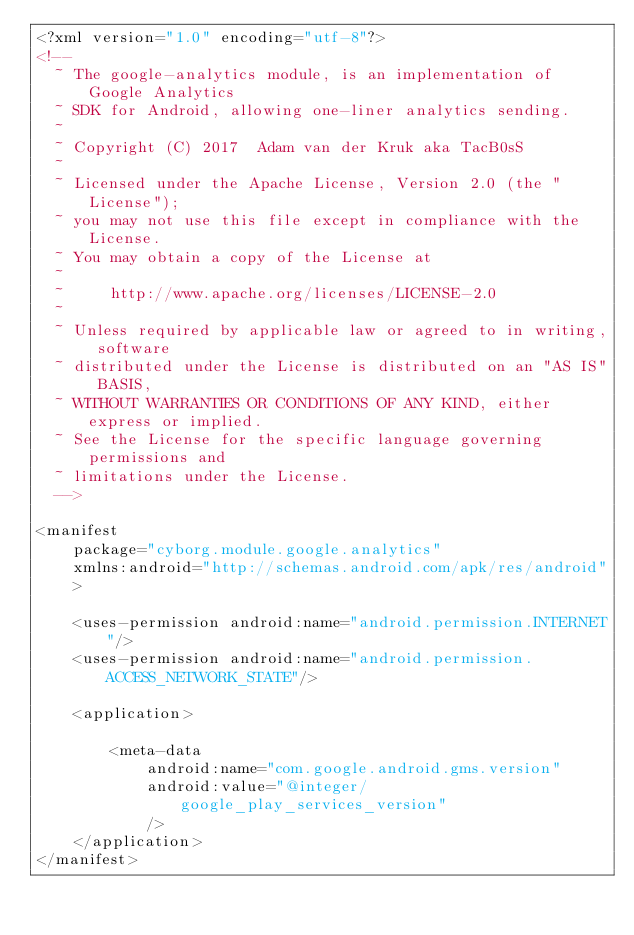Convert code to text. <code><loc_0><loc_0><loc_500><loc_500><_XML_><?xml version="1.0" encoding="utf-8"?>
<!--
  ~ The google-analytics module, is an implementation of Google Analytics
  ~ SDK for Android, allowing one-liner analytics sending.
  ~
  ~ Copyright (C) 2017  Adam van der Kruk aka TacB0sS
  ~
  ~ Licensed under the Apache License, Version 2.0 (the "License");
  ~ you may not use this file except in compliance with the License.
  ~ You may obtain a copy of the License at
  ~
  ~     http://www.apache.org/licenses/LICENSE-2.0
  ~
  ~ Unless required by applicable law or agreed to in writing, software
  ~ distributed under the License is distributed on an "AS IS" BASIS,
  ~ WITHOUT WARRANTIES OR CONDITIONS OF ANY KIND, either express or implied.
  ~ See the License for the specific language governing permissions and
  ~ limitations under the License.
  -->

<manifest
    package="cyborg.module.google.analytics"
    xmlns:android="http://schemas.android.com/apk/res/android"
    >

    <uses-permission android:name="android.permission.INTERNET"/>
    <uses-permission android:name="android.permission.ACCESS_NETWORK_STATE"/>

    <application>

        <meta-data
            android:name="com.google.android.gms.version"
            android:value="@integer/google_play_services_version"
            />
    </application>
</manifest></code> 